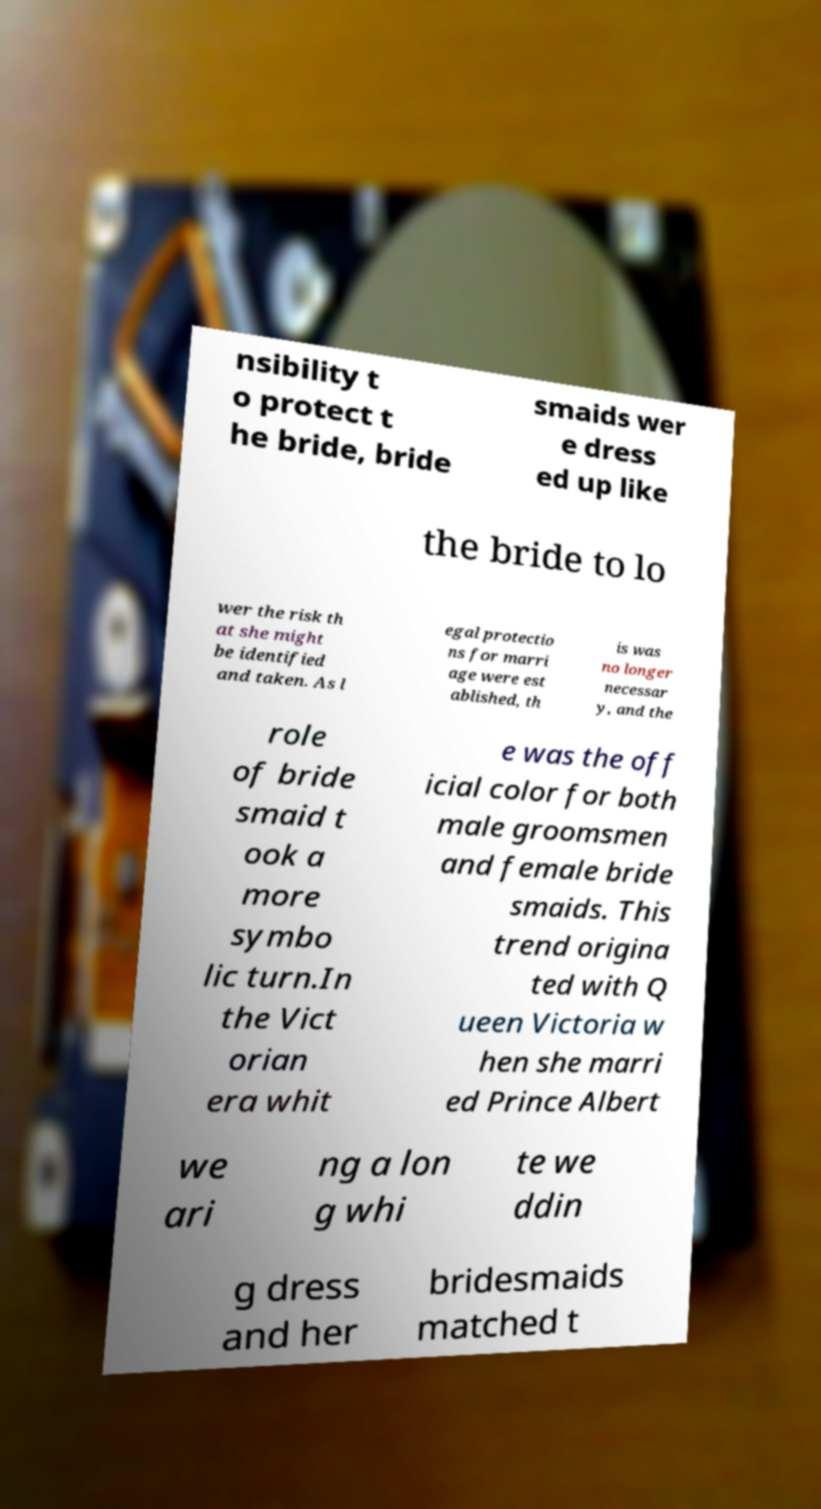Please identify and transcribe the text found in this image. nsibility t o protect t he bride, bride smaids wer e dress ed up like the bride to lo wer the risk th at she might be identified and taken. As l egal protectio ns for marri age were est ablished, th is was no longer necessar y, and the role of bride smaid t ook a more symbo lic turn.In the Vict orian era whit e was the off icial color for both male groomsmen and female bride smaids. This trend origina ted with Q ueen Victoria w hen she marri ed Prince Albert we ari ng a lon g whi te we ddin g dress and her bridesmaids matched t 